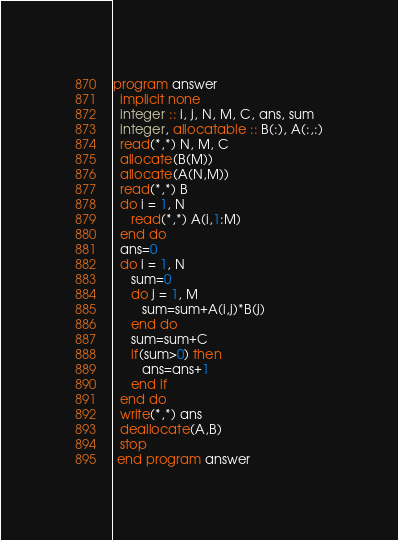Convert code to text. <code><loc_0><loc_0><loc_500><loc_500><_FORTRAN_>program answer
  implicit none
  integer :: i, j, N, M, C, ans, sum
  integer, allocatable :: B(:), A(:,:)
  read(*,*) N, M, C
  allocate(B(M))
  allocate(A(N,M))
  read(*,*) B
  do i = 1, N
     read(*,*) A(i,1:M)
  end do
  ans=0
  do i = 1, N
     sum=0
     do j = 1, M
        sum=sum+A(i,j)*B(j)
     end do
     sum=sum+C
     if(sum>0) then
        ans=ans+1
     end if
  end do
  write(*,*) ans
  deallocate(A,B)
  stop
 end program answer</code> 